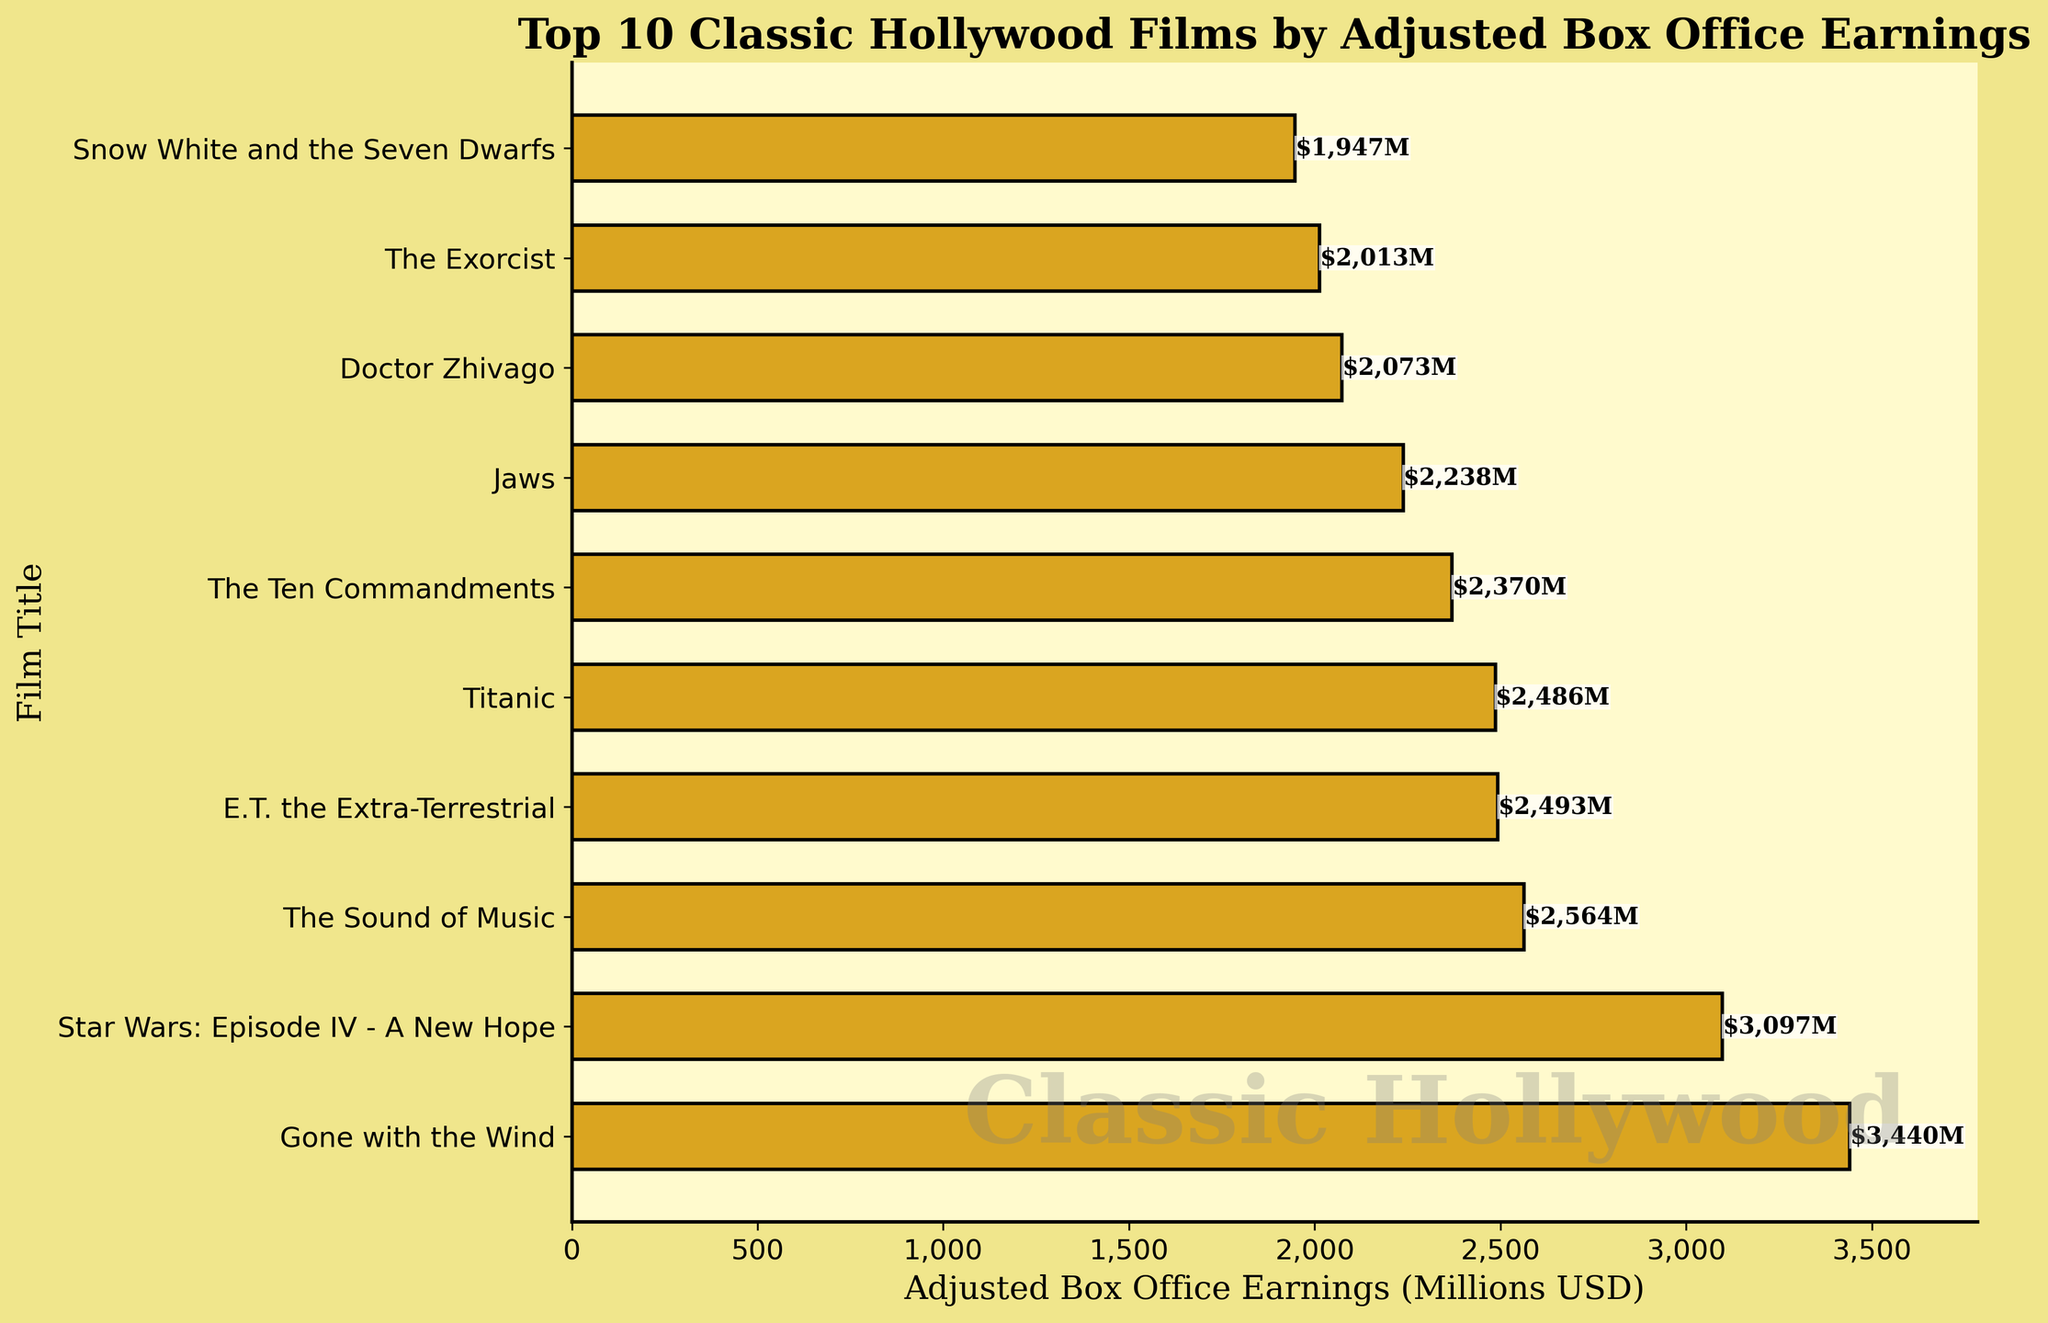How many films have adjusted box office earnings of more than 2.5 billion USD? To answer this, identify the bars representing films with earnings greater than 2.5 billion USD. These films are "Gone with the Wind," "Star Wars: Episode IV - A New Hope," and "The Sound of Music." That's three films.
Answer: 3 Which film has the highest adjusted box office earnings, and what is the amount? Look for the film with the longest bar in the horizontal bar chart. "Gone with the Wind" has the highest earnings at 3,440 million USD.
Answer: Gone with the Wind, 3,440 million USD What is the adjusted box office earnings difference between "Titanic" and "Jaws"? Identify the earnings for both films from the chart: "Titanic" with 2,486 million USD and "Jaws" with 2,238 million USD. Subtract Jaws' earnings from Titanic's earnings: 2,486 - 2,238 = 248 million USD.
Answer: 248 million USD Which two films have the closest adjusted box office earnings, and what is their difference? Find bars with earnings close in length. "The Exorcist" and "Snow White and the Seven Dwarfs" have earnings of 2,013 million USD and 1,947 million USD, respectively. Their difference is 2,013 - 1,947 = 66 million USD.
Answer: The Exorcist and Snow White and the Seven Dwarfs, 66 million USD List the films with adjusted box office earnings greater than 3 billion USD. Scan the bars to find those with earnings above 3 billion USD. "Gone with the Wind" and "Star Wars: Episode IV - A New Hope" both exceed 3 billion USD.
Answer: Gone with the Wind, Star Wars: Episode IV - A New Hope What is the sum of adjusted box office earnings for the top 3 films? Identify the earnings of the top 3 films: "Gone with the Wind" (3,440 million USD), "Star Wars: Episode IV - A New Hope" (3,097 million USD), and "The Sound of Music" (2,564 million USD). Add these values: 3,440 + 3,097 + 2,564 = 9,101 million USD.
Answer: 9,101 million USD Which film has the third highest adjusted box office earnings, and what is the amount? From the chart, the third longest bar represents "The Sound of Music," with earnings of 2,564 million USD.
Answer: The Sound of Music, 2,564 million USD Compare the adjusted box office earnings of "E.T. the Extra-Terrestrial" and "Doctor Zhivago". Which is higher, and by how much? "E.T. the Extra-Terrestrial" has 2,493 million USD, and "Doctor Zhivago" has 2,073 million USD. Subtract the two: 2,493 - 2,073 = 420 million USD. "E.T. the Extra-Terrestrial" is higher by 420 million USD.
Answer: E.T. the Extra-Terrestrial, 420 million USD What is the average adjusted box office earnings of the top 5 films? Identify the earnings of the top 5 films: "Gone with the Wind" (3,440 million USD), "Star Wars: Episode IV - A New Hope" (3,097 million USD), "The Sound of Music" (2,564 million USD), "E.T. the Extra-Terrestrial" (2,493 million USD), and "Titanic" (2,486 million USD). Sum these values: 3,440 + 3,097 + 2,564 + 2,493 + 2,486 = 14,080 million USD. Divide by 5: 14,080 / 5 = 2,816 million USD.
Answer: 2,816 million USD 